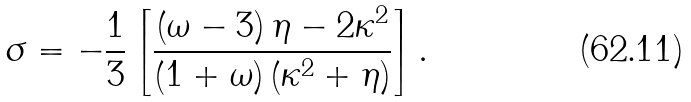Convert formula to latex. <formula><loc_0><loc_0><loc_500><loc_500>\sigma = - \frac { 1 } { 3 } \left [ \frac { \left ( \omega - 3 \right ) \eta - 2 \kappa ^ { 2 } } { \left ( 1 + \omega \right ) \left ( \kappa ^ { 2 } + \eta \right ) } \right ] .</formula> 